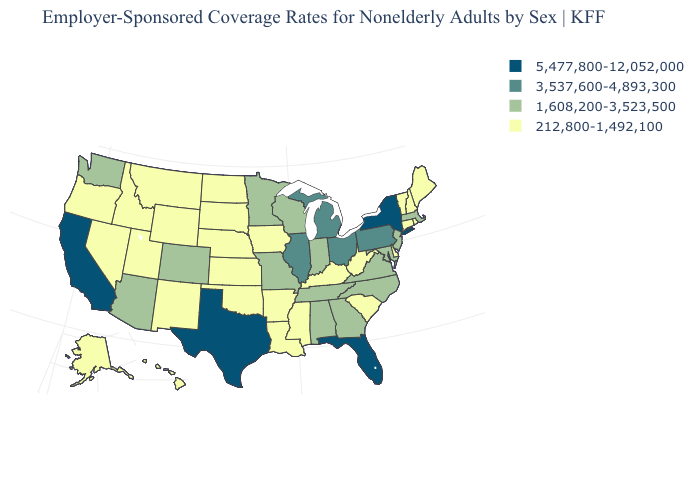What is the value of Vermont?
Give a very brief answer. 212,800-1,492,100. Does the first symbol in the legend represent the smallest category?
Answer briefly. No. Which states have the highest value in the USA?
Quick response, please. California, Florida, New York, Texas. What is the lowest value in the MidWest?
Keep it brief. 212,800-1,492,100. What is the highest value in the USA?
Quick response, please. 5,477,800-12,052,000. Name the states that have a value in the range 5,477,800-12,052,000?
Write a very short answer. California, Florida, New York, Texas. Name the states that have a value in the range 1,608,200-3,523,500?
Be succinct. Alabama, Arizona, Colorado, Georgia, Indiana, Maryland, Massachusetts, Minnesota, Missouri, New Jersey, North Carolina, Tennessee, Virginia, Washington, Wisconsin. Does Pennsylvania have a lower value than Indiana?
Answer briefly. No. What is the value of Kentucky?
Keep it brief. 212,800-1,492,100. Is the legend a continuous bar?
Answer briefly. No. Which states hav the highest value in the West?
Keep it brief. California. What is the value of South Dakota?
Short answer required. 212,800-1,492,100. Is the legend a continuous bar?
Answer briefly. No. Does Virginia have a higher value than Michigan?
Short answer required. No. 